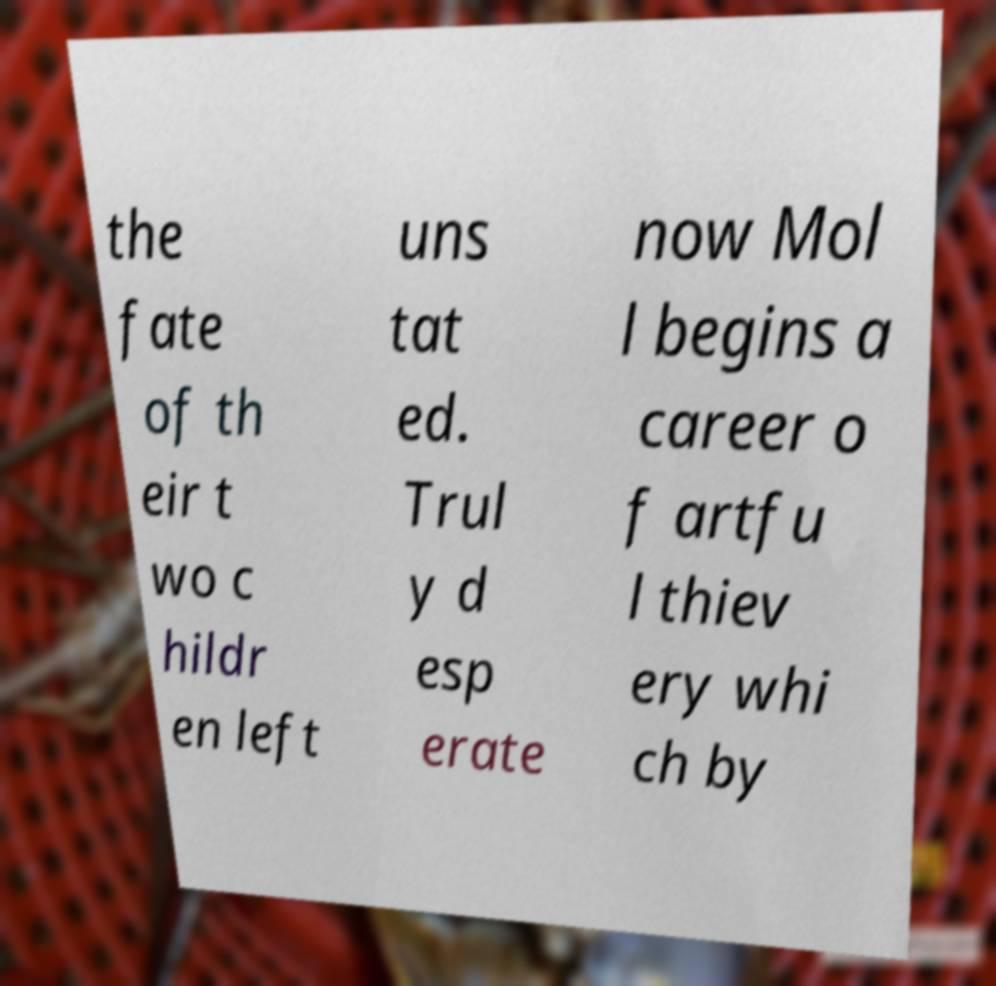Could you extract and type out the text from this image? the fate of th eir t wo c hildr en left uns tat ed. Trul y d esp erate now Mol l begins a career o f artfu l thiev ery whi ch by 